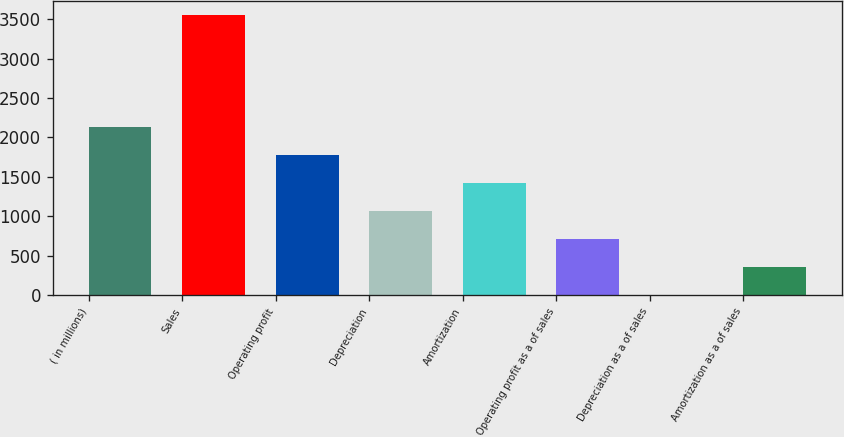<chart> <loc_0><loc_0><loc_500><loc_500><bar_chart><fcel>( in millions)<fcel>Sales<fcel>Operating profit<fcel>Depreciation<fcel>Amortization<fcel>Operating profit as a of sales<fcel>Depreciation as a of sales<fcel>Amortization as a of sales<nl><fcel>2130.28<fcel>3549.8<fcel>1775.4<fcel>1065.64<fcel>1420.52<fcel>710.76<fcel>1<fcel>355.88<nl></chart> 